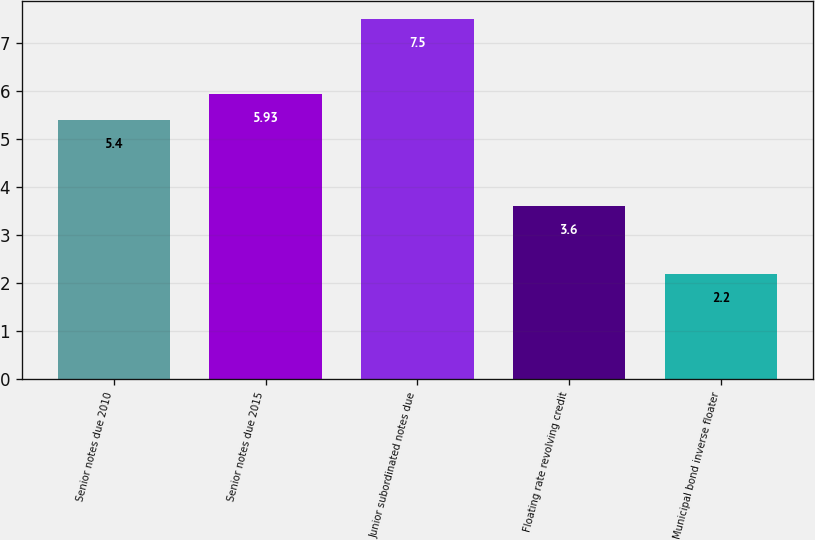Convert chart to OTSL. <chart><loc_0><loc_0><loc_500><loc_500><bar_chart><fcel>Senior notes due 2010<fcel>Senior notes due 2015<fcel>Junior subordinated notes due<fcel>Floating rate revolving credit<fcel>Municipal bond inverse floater<nl><fcel>5.4<fcel>5.93<fcel>7.5<fcel>3.6<fcel>2.2<nl></chart> 